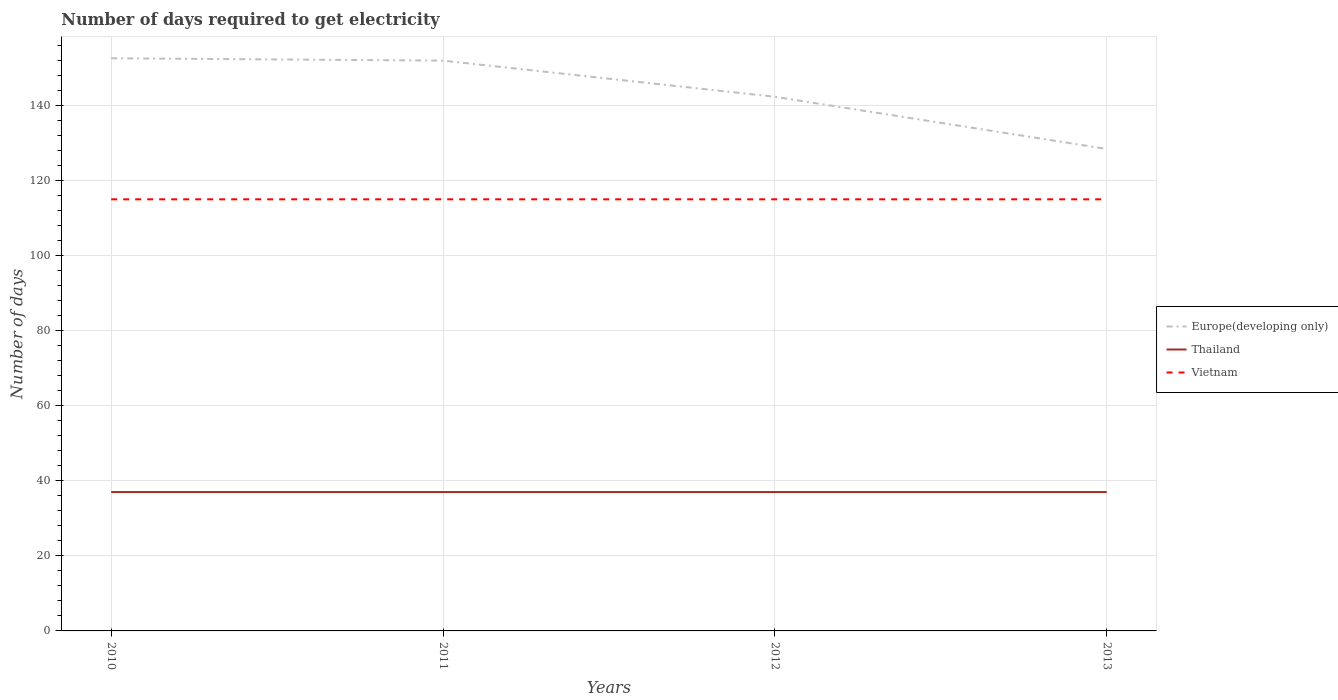Is the number of lines equal to the number of legend labels?
Give a very brief answer. Yes. Across all years, what is the maximum number of days required to get electricity in in Thailand?
Your answer should be compact. 37. What is the difference between the highest and the second highest number of days required to get electricity in in Vietnam?
Keep it short and to the point. 0. Is the number of days required to get electricity in in Thailand strictly greater than the number of days required to get electricity in in Vietnam over the years?
Your answer should be compact. Yes. How many lines are there?
Give a very brief answer. 3. How many years are there in the graph?
Give a very brief answer. 4. Does the graph contain any zero values?
Your response must be concise. No. Does the graph contain grids?
Make the answer very short. Yes. How many legend labels are there?
Offer a very short reply. 3. How are the legend labels stacked?
Offer a terse response. Vertical. What is the title of the graph?
Provide a succinct answer. Number of days required to get electricity. What is the label or title of the Y-axis?
Keep it short and to the point. Number of days. What is the Number of days of Europe(developing only) in 2010?
Offer a terse response. 152.58. What is the Number of days in Thailand in 2010?
Your answer should be very brief. 37. What is the Number of days in Vietnam in 2010?
Offer a terse response. 115. What is the Number of days in Europe(developing only) in 2011?
Offer a terse response. 151.95. What is the Number of days of Vietnam in 2011?
Ensure brevity in your answer.  115. What is the Number of days in Europe(developing only) in 2012?
Keep it short and to the point. 142.32. What is the Number of days in Vietnam in 2012?
Offer a very short reply. 115. What is the Number of days in Europe(developing only) in 2013?
Provide a short and direct response. 128.42. What is the Number of days in Vietnam in 2013?
Offer a very short reply. 115. Across all years, what is the maximum Number of days in Europe(developing only)?
Your answer should be compact. 152.58. Across all years, what is the maximum Number of days of Vietnam?
Offer a terse response. 115. Across all years, what is the minimum Number of days of Europe(developing only)?
Your answer should be compact. 128.42. Across all years, what is the minimum Number of days in Vietnam?
Provide a short and direct response. 115. What is the total Number of days in Europe(developing only) in the graph?
Your answer should be very brief. 575.26. What is the total Number of days in Thailand in the graph?
Provide a short and direct response. 148. What is the total Number of days of Vietnam in the graph?
Provide a short and direct response. 460. What is the difference between the Number of days of Europe(developing only) in 2010 and that in 2011?
Offer a very short reply. 0.63. What is the difference between the Number of days of Thailand in 2010 and that in 2011?
Provide a short and direct response. 0. What is the difference between the Number of days of Europe(developing only) in 2010 and that in 2012?
Your answer should be compact. 10.26. What is the difference between the Number of days in Europe(developing only) in 2010 and that in 2013?
Your response must be concise. 24.16. What is the difference between the Number of days in Thailand in 2010 and that in 2013?
Make the answer very short. 0. What is the difference between the Number of days of Vietnam in 2010 and that in 2013?
Provide a succinct answer. 0. What is the difference between the Number of days in Europe(developing only) in 2011 and that in 2012?
Make the answer very short. 9.63. What is the difference between the Number of days of Europe(developing only) in 2011 and that in 2013?
Provide a succinct answer. 23.53. What is the difference between the Number of days of Thailand in 2011 and that in 2013?
Provide a succinct answer. 0. What is the difference between the Number of days of Vietnam in 2011 and that in 2013?
Your answer should be compact. 0. What is the difference between the Number of days in Europe(developing only) in 2012 and that in 2013?
Make the answer very short. 13.89. What is the difference between the Number of days in Thailand in 2012 and that in 2013?
Ensure brevity in your answer.  0. What is the difference between the Number of days of Europe(developing only) in 2010 and the Number of days of Thailand in 2011?
Give a very brief answer. 115.58. What is the difference between the Number of days of Europe(developing only) in 2010 and the Number of days of Vietnam in 2011?
Your answer should be compact. 37.58. What is the difference between the Number of days in Thailand in 2010 and the Number of days in Vietnam in 2011?
Ensure brevity in your answer.  -78. What is the difference between the Number of days of Europe(developing only) in 2010 and the Number of days of Thailand in 2012?
Your response must be concise. 115.58. What is the difference between the Number of days in Europe(developing only) in 2010 and the Number of days in Vietnam in 2012?
Offer a terse response. 37.58. What is the difference between the Number of days of Thailand in 2010 and the Number of days of Vietnam in 2012?
Offer a terse response. -78. What is the difference between the Number of days of Europe(developing only) in 2010 and the Number of days of Thailand in 2013?
Provide a short and direct response. 115.58. What is the difference between the Number of days of Europe(developing only) in 2010 and the Number of days of Vietnam in 2013?
Ensure brevity in your answer.  37.58. What is the difference between the Number of days of Thailand in 2010 and the Number of days of Vietnam in 2013?
Ensure brevity in your answer.  -78. What is the difference between the Number of days of Europe(developing only) in 2011 and the Number of days of Thailand in 2012?
Your answer should be very brief. 114.95. What is the difference between the Number of days of Europe(developing only) in 2011 and the Number of days of Vietnam in 2012?
Provide a succinct answer. 36.95. What is the difference between the Number of days of Thailand in 2011 and the Number of days of Vietnam in 2012?
Ensure brevity in your answer.  -78. What is the difference between the Number of days in Europe(developing only) in 2011 and the Number of days in Thailand in 2013?
Your answer should be very brief. 114.95. What is the difference between the Number of days of Europe(developing only) in 2011 and the Number of days of Vietnam in 2013?
Your answer should be compact. 36.95. What is the difference between the Number of days in Thailand in 2011 and the Number of days in Vietnam in 2013?
Give a very brief answer. -78. What is the difference between the Number of days in Europe(developing only) in 2012 and the Number of days in Thailand in 2013?
Provide a short and direct response. 105.32. What is the difference between the Number of days in Europe(developing only) in 2012 and the Number of days in Vietnam in 2013?
Provide a succinct answer. 27.32. What is the difference between the Number of days in Thailand in 2012 and the Number of days in Vietnam in 2013?
Keep it short and to the point. -78. What is the average Number of days in Europe(developing only) per year?
Make the answer very short. 143.82. What is the average Number of days in Vietnam per year?
Give a very brief answer. 115. In the year 2010, what is the difference between the Number of days in Europe(developing only) and Number of days in Thailand?
Provide a succinct answer. 115.58. In the year 2010, what is the difference between the Number of days of Europe(developing only) and Number of days of Vietnam?
Offer a terse response. 37.58. In the year 2010, what is the difference between the Number of days in Thailand and Number of days in Vietnam?
Your answer should be compact. -78. In the year 2011, what is the difference between the Number of days in Europe(developing only) and Number of days in Thailand?
Your answer should be compact. 114.95. In the year 2011, what is the difference between the Number of days of Europe(developing only) and Number of days of Vietnam?
Your response must be concise. 36.95. In the year 2011, what is the difference between the Number of days of Thailand and Number of days of Vietnam?
Ensure brevity in your answer.  -78. In the year 2012, what is the difference between the Number of days in Europe(developing only) and Number of days in Thailand?
Your answer should be compact. 105.32. In the year 2012, what is the difference between the Number of days of Europe(developing only) and Number of days of Vietnam?
Give a very brief answer. 27.32. In the year 2012, what is the difference between the Number of days in Thailand and Number of days in Vietnam?
Give a very brief answer. -78. In the year 2013, what is the difference between the Number of days in Europe(developing only) and Number of days in Thailand?
Ensure brevity in your answer.  91.42. In the year 2013, what is the difference between the Number of days in Europe(developing only) and Number of days in Vietnam?
Provide a short and direct response. 13.42. In the year 2013, what is the difference between the Number of days in Thailand and Number of days in Vietnam?
Give a very brief answer. -78. What is the ratio of the Number of days in Europe(developing only) in 2010 to that in 2011?
Keep it short and to the point. 1. What is the ratio of the Number of days in Europe(developing only) in 2010 to that in 2012?
Offer a terse response. 1.07. What is the ratio of the Number of days of Vietnam in 2010 to that in 2012?
Make the answer very short. 1. What is the ratio of the Number of days in Europe(developing only) in 2010 to that in 2013?
Your answer should be compact. 1.19. What is the ratio of the Number of days in Thailand in 2010 to that in 2013?
Give a very brief answer. 1. What is the ratio of the Number of days in Vietnam in 2010 to that in 2013?
Give a very brief answer. 1. What is the ratio of the Number of days in Europe(developing only) in 2011 to that in 2012?
Give a very brief answer. 1.07. What is the ratio of the Number of days of Thailand in 2011 to that in 2012?
Provide a short and direct response. 1. What is the ratio of the Number of days of Europe(developing only) in 2011 to that in 2013?
Provide a short and direct response. 1.18. What is the ratio of the Number of days of Vietnam in 2011 to that in 2013?
Your response must be concise. 1. What is the ratio of the Number of days of Europe(developing only) in 2012 to that in 2013?
Offer a terse response. 1.11. What is the ratio of the Number of days of Thailand in 2012 to that in 2013?
Offer a terse response. 1. What is the ratio of the Number of days of Vietnam in 2012 to that in 2013?
Your answer should be compact. 1. What is the difference between the highest and the second highest Number of days of Europe(developing only)?
Provide a short and direct response. 0.63. What is the difference between the highest and the lowest Number of days in Europe(developing only)?
Offer a very short reply. 24.16. What is the difference between the highest and the lowest Number of days in Vietnam?
Offer a terse response. 0. 